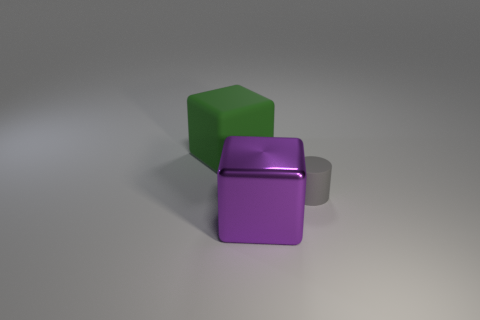Can you describe the texture on the surfaces of the objects? Certainly. The surfaces of the objects appear smooth and uniformly colored. The purple and green blocks exhibit a slight matte texture, while the gray object seems to have a metallic texture that reflects light, giving it a slightly shiny appearance. 